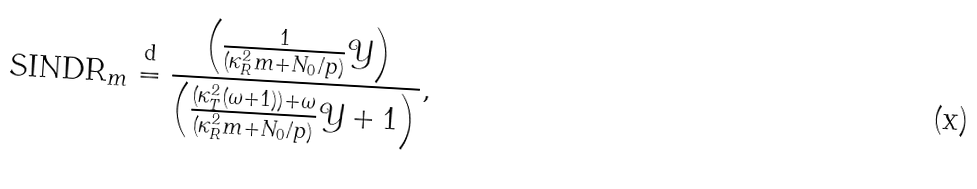<formula> <loc_0><loc_0><loc_500><loc_500>\text {SINDR} _ { m } \overset { \text {d} } = \frac { \left ( \frac { 1 } { ( \kappa ^ { 2 } _ { R } m + N _ { 0 } / p ) } \mathcal { Y } \right ) } { \left ( \frac { ( \kappa ^ { 2 } _ { T } ( \omega + 1 ) ) + \omega } { ( \kappa ^ { 2 } _ { R } m + N _ { 0 } / p ) } \mathcal { Y } + 1 \right ) } ,</formula> 